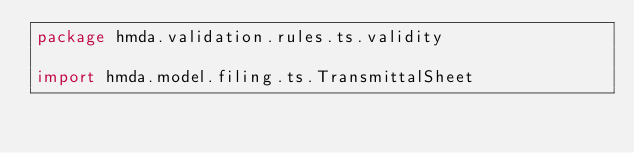Convert code to text. <code><loc_0><loc_0><loc_500><loc_500><_Scala_>package hmda.validation.rules.ts.validity

import hmda.model.filing.ts.TransmittalSheet</code> 